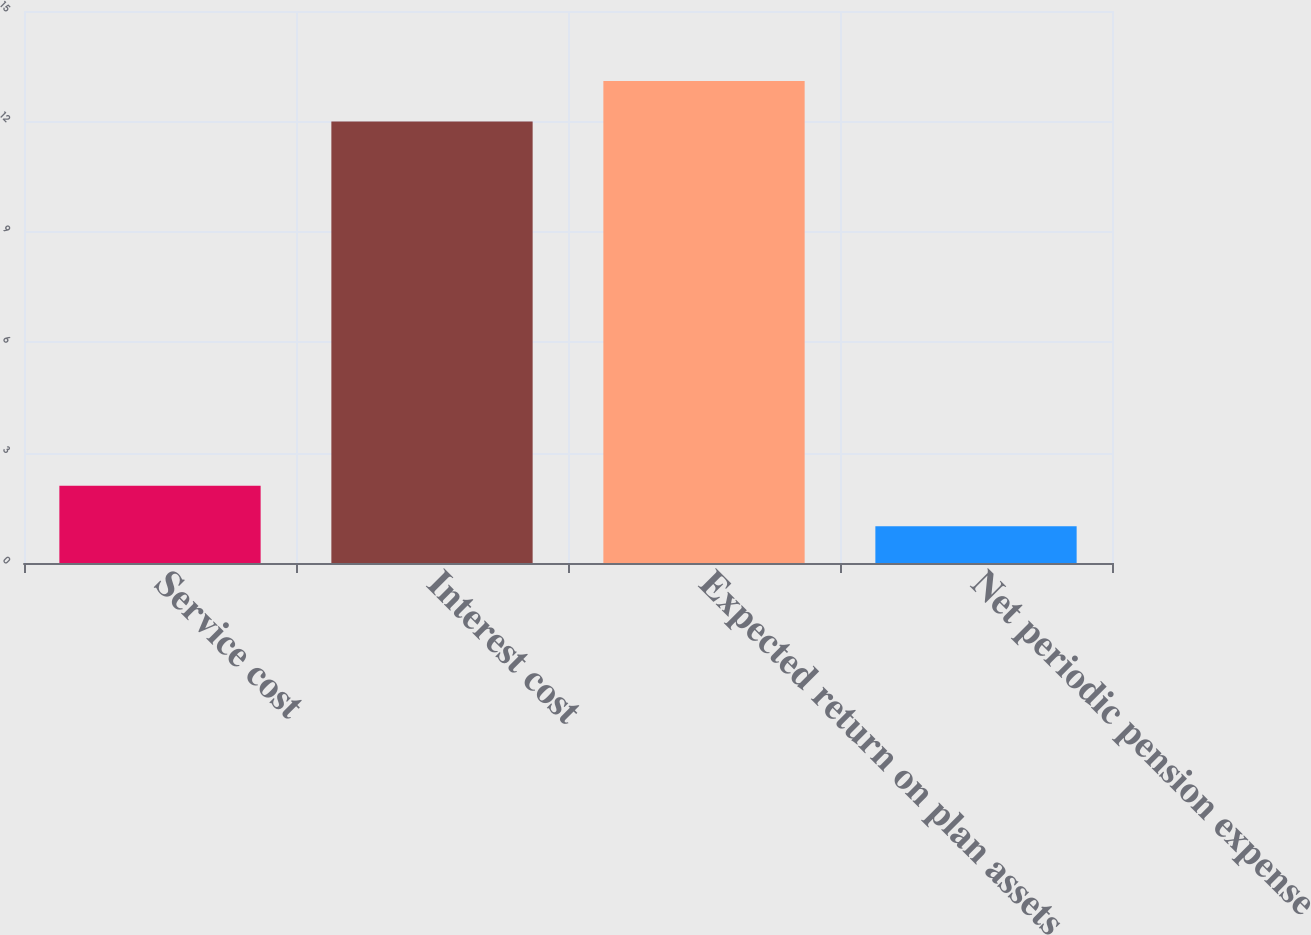Convert chart to OTSL. <chart><loc_0><loc_0><loc_500><loc_500><bar_chart><fcel>Service cost<fcel>Interest cost<fcel>Expected return on plan assets<fcel>Net periodic pension expense<nl><fcel>2.1<fcel>12<fcel>13.1<fcel>1<nl></chart> 